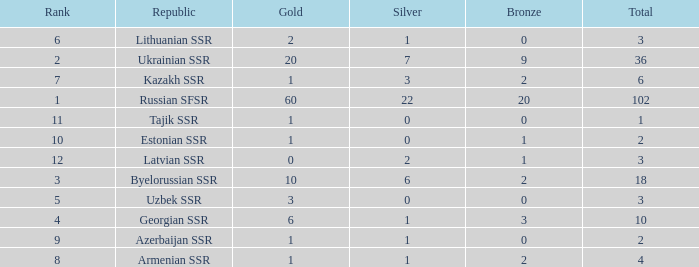What is the sum of silvers for teams with ranks over 3 and totals under 2? 0.0. 